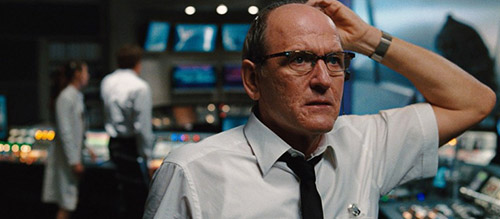What does the character's body language suggest about his emotions or thoughts? The character's body language, particularly his hand raised to scratch his head, typically indicates a moment of perplexity or deep thought. This kind of gesture often reflects internal debates or critical thinking, likely about a significant issue or decision in his work. His stern facial expression and focused gaze also suggest a high level of concern or engagement with a serious matter, emphasizing his responsibility and the stress associated with his role in the high-stakes environment of a newsroom. 